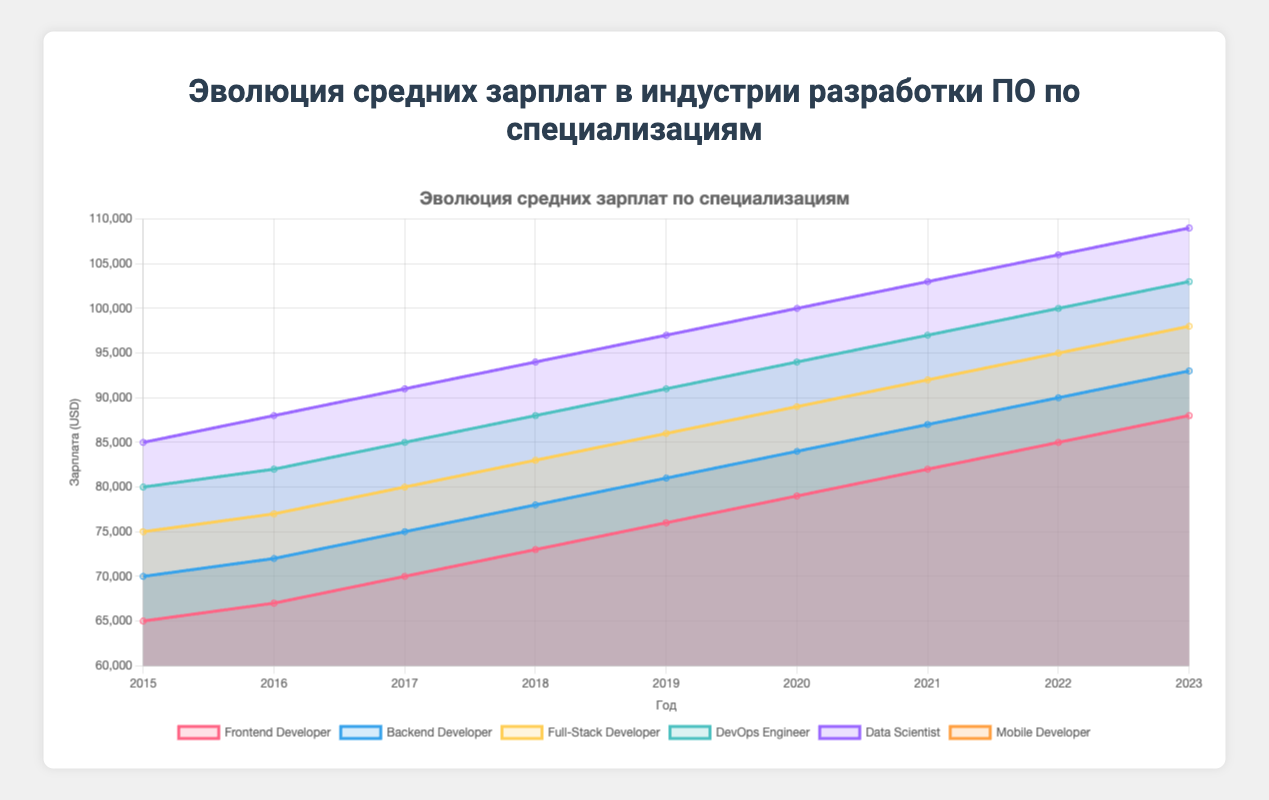Какова самая высокая средняя зарплата в 2023 году и к какой специализации она относится? На вертикальной оси (указан заработок в USD), а на горизонтальной оси (указан год) максимальная зарплата в 2023 году соответствует Data Scientist, которая составляет 109000.
Answer: 109000, Data Scientist Какая специализация имела наибольший рост зарплаты между 2015 и 2023 годами? Вычислим разницу в заработной плате для каждой специализации между 2023 и 2015 годами и сравним. Самый большой прирост у Data Scientist: 109000 - 85000 = 24000.
Answer: Data Scientist Как изменилась зарплата у Full-Stack Developer с 2018 по 2021 год? Разница в зарплате для Full-Stack Developer между 2021 и 2018 годами составляет 92000 - 83000 = 9000.
Answer: Увеличилась на 9000 Какая специализация имеет самые стабильные увеличения зарплат ежегодно? Сравнивая годовые приросты зарплаты, наименьшие и стабильные изменения видны у Frontend Developer и Mobile Developer, где ежегодные приросты равны 3000.
Answer: Frontend Developer и Mobile Developer Какая разница в средней зарплате между Frontend Developer и DevOps Engineer в 2020 году? В 2020 году зарплата Frontend Developer составляет 79000, а DevOps Engineer — 94000. Разница: 94000 - 79000 = 15000.
Answer: 15000 Какой год стал переломным для равноценной зарплаты Backend Developer и Mobile Developer? В 2015 году зарплаты у них были равны — по 70000.
Answer: 2015 год Какая специализация получила наименьший прирост зарплаты с 2015 по 2023 годы? Разница в зарплате между 2023 и 2015 годами минимальна у Frontend Developer: 88000 - 65000 = 23000.
Answer: Frontend Developer Какие специализации имели одинаковую зарплату в 2016 году? В 2016 году Backend Developer и Mobile Developer имели одинаковую зарплату, которая составила 72000.
Answer: Backend Developer и Mobile Developer 